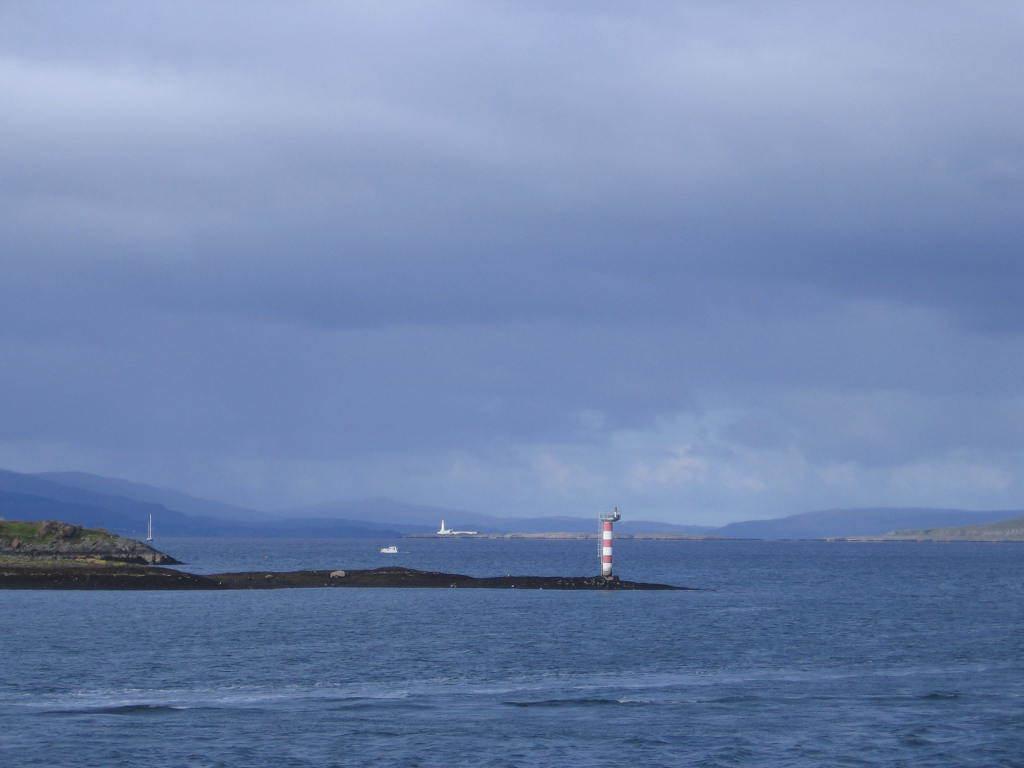In one or two sentences, can you explain what this image depicts? In this picture we can see a tower on the ground, boat on water, grass, mountains and in the background we can see the sky with clouds. 